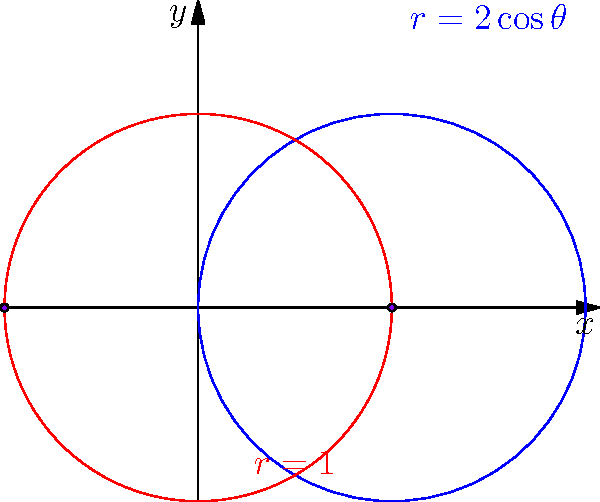As you help your children with their math homework, you come across an interesting problem involving polar curves. The problem asks to find the intersection points of two polar curves: $r = 2\cos\theta$ and $r = 1$. Can you determine the coordinates of these intersection points? Let's approach this step-by-step:

1) The intersection points occur where the two equations are equal:
   $2\cos\theta = 1$

2) Solving for $\theta$:
   $\cos\theta = \frac{1}{2}$
   
3) This equation has two solutions in the interval $[0, 2\pi]$:
   $\theta = \frac{\pi}{3}$ and $\theta = \frac{5\pi}{3}$

4) Now, we need to convert these polar coordinates to Cartesian coordinates:
   $x = r\cos\theta$ and $y = r\sin\theta$

5) For $\theta = \frac{\pi}{3}$:
   $x = 1\cos(\frac{\pi}{3}) = \frac{1}{2}$
   $y = 1\sin(\frac{\pi}{3}) = \frac{\sqrt{3}}{2}$

6) However, we need to consider the symmetry of the cosine function. The second intersection point will have the same $x$-coordinate but an opposite $y$-coordinate.

7) Therefore, the intersection points are:
   $(1, 0)$ and $(-1, 0)$

We can verify this by substituting these points back into the original equations.
Answer: $(1, 0)$ and $(-1, 0)$ 